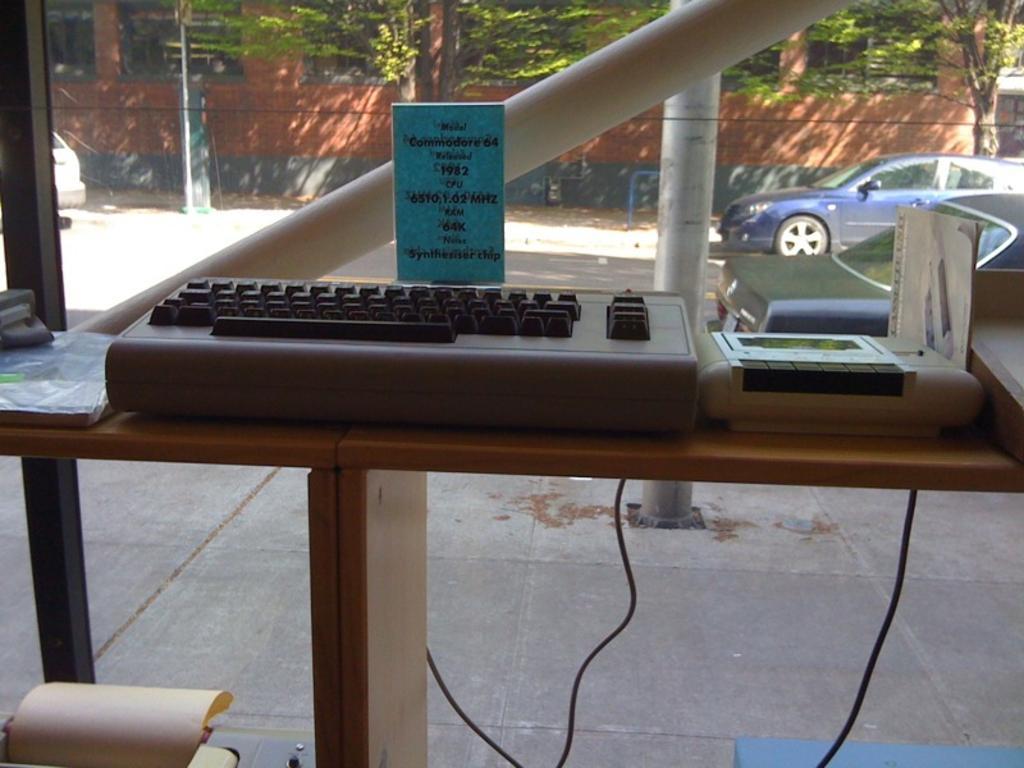Could you give a brief overview of what you see in this image? In the photograph there is a typing machine another gadget right side that, in the background there is a window , back side the window there is a building , trees, a pole and a car. 